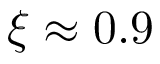<formula> <loc_0><loc_0><loc_500><loc_500>\xi \approx 0 . 9</formula> 